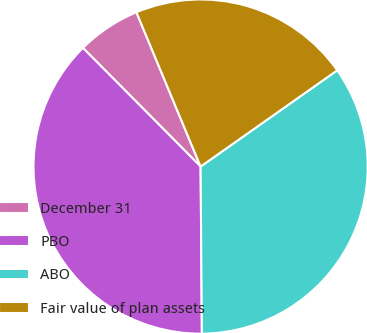Convert chart to OTSL. <chart><loc_0><loc_0><loc_500><loc_500><pie_chart><fcel>December 31<fcel>PBO<fcel>ABO<fcel>Fair value of plan assets<nl><fcel>6.16%<fcel>37.69%<fcel>34.65%<fcel>21.51%<nl></chart> 